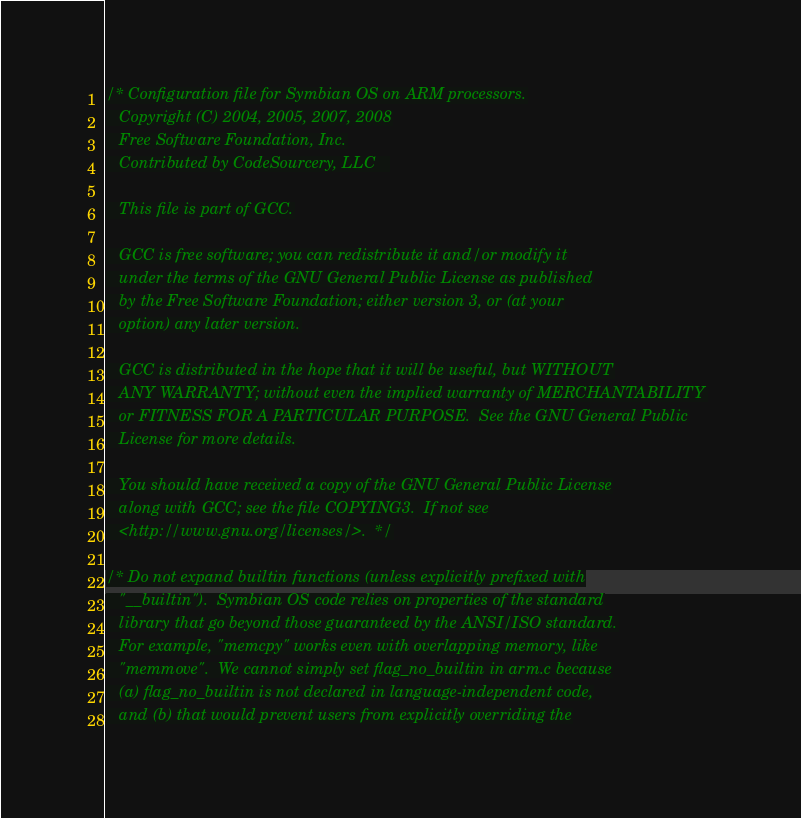<code> <loc_0><loc_0><loc_500><loc_500><_C_>/* Configuration file for Symbian OS on ARM processors.
   Copyright (C) 2004, 2005, 2007, 2008
   Free Software Foundation, Inc.
   Contributed by CodeSourcery, LLC   

   This file is part of GCC.

   GCC is free software; you can redistribute it and/or modify it
   under the terms of the GNU General Public License as published
   by the Free Software Foundation; either version 3, or (at your
   option) any later version.

   GCC is distributed in the hope that it will be useful, but WITHOUT
   ANY WARRANTY; without even the implied warranty of MERCHANTABILITY
   or FITNESS FOR A PARTICULAR PURPOSE.  See the GNU General Public
   License for more details.

   You should have received a copy of the GNU General Public License
   along with GCC; see the file COPYING3.  If not see
   <http://www.gnu.org/licenses/>.  */

/* Do not expand builtin functions (unless explicitly prefixed with
   "__builtin").  Symbian OS code relies on properties of the standard
   library that go beyond those guaranteed by the ANSI/ISO standard.
   For example, "memcpy" works even with overlapping memory, like
   "memmove".  We cannot simply set flag_no_builtin in arm.c because
   (a) flag_no_builtin is not declared in language-independent code,
   and (b) that would prevent users from explicitly overriding the</code> 